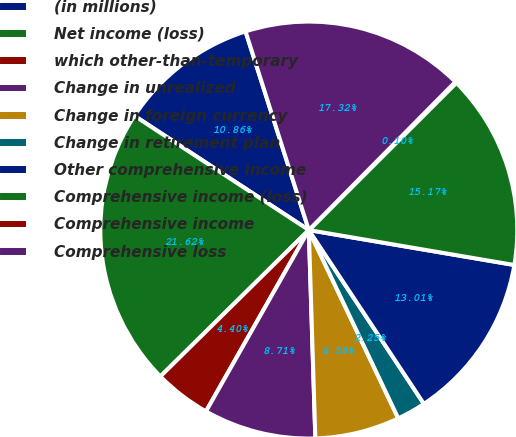Convert chart. <chart><loc_0><loc_0><loc_500><loc_500><pie_chart><fcel>(in millions)<fcel>Net income (loss)<fcel>which other-than-temporary<fcel>Change in unrealized<fcel>Change in foreign currency<fcel>Change in retirement plan<fcel>Other comprehensive income<fcel>Comprehensive income (loss)<fcel>Comprehensive income<fcel>Comprehensive loss<nl><fcel>10.86%<fcel>21.62%<fcel>4.4%<fcel>8.71%<fcel>6.56%<fcel>2.25%<fcel>13.01%<fcel>15.17%<fcel>0.1%<fcel>17.32%<nl></chart> 